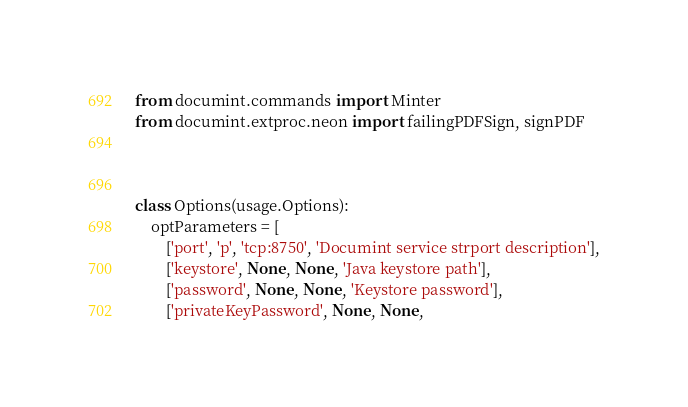<code> <loc_0><loc_0><loc_500><loc_500><_Python_>from documint.commands import Minter
from documint.extproc.neon import failingPDFSign, signPDF



class Options(usage.Options):
    optParameters = [
        ['port', 'p', 'tcp:8750', 'Documint service strport description'],
        ['keystore', None, None, 'Java keystore path'],
        ['password', None, None, 'Keystore password'],
        ['privateKeyPassword', None, None,</code> 